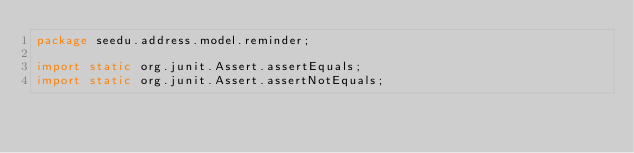<code> <loc_0><loc_0><loc_500><loc_500><_Java_>package seedu.address.model.reminder;

import static org.junit.Assert.assertEquals;
import static org.junit.Assert.assertNotEquals;</code> 